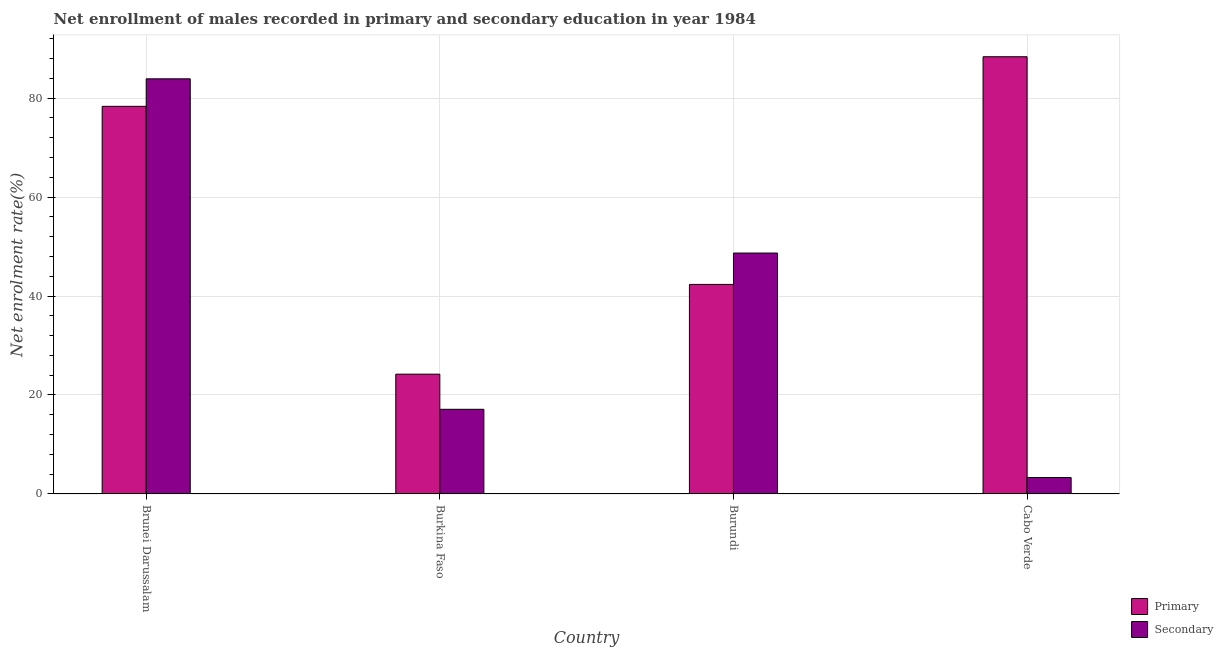How many different coloured bars are there?
Keep it short and to the point. 2. Are the number of bars per tick equal to the number of legend labels?
Keep it short and to the point. Yes. How many bars are there on the 2nd tick from the left?
Offer a terse response. 2. How many bars are there on the 2nd tick from the right?
Your response must be concise. 2. What is the label of the 4th group of bars from the left?
Your response must be concise. Cabo Verde. What is the enrollment rate in primary education in Brunei Darussalam?
Keep it short and to the point. 78.33. Across all countries, what is the maximum enrollment rate in primary education?
Offer a very short reply. 88.36. Across all countries, what is the minimum enrollment rate in primary education?
Give a very brief answer. 24.21. In which country was the enrollment rate in secondary education maximum?
Ensure brevity in your answer.  Brunei Darussalam. In which country was the enrollment rate in secondary education minimum?
Offer a very short reply. Cabo Verde. What is the total enrollment rate in primary education in the graph?
Your answer should be very brief. 233.25. What is the difference between the enrollment rate in secondary education in Brunei Darussalam and that in Cabo Verde?
Your response must be concise. 80.56. What is the difference between the enrollment rate in secondary education in Brunei Darussalam and the enrollment rate in primary education in Burundi?
Your answer should be compact. 41.55. What is the average enrollment rate in primary education per country?
Provide a short and direct response. 58.31. What is the difference between the enrollment rate in secondary education and enrollment rate in primary education in Burkina Faso?
Provide a short and direct response. -7.1. In how many countries, is the enrollment rate in secondary education greater than 44 %?
Keep it short and to the point. 2. What is the ratio of the enrollment rate in primary education in Brunei Darussalam to that in Burundi?
Offer a terse response. 1.85. Is the enrollment rate in primary education in Brunei Darussalam less than that in Burundi?
Keep it short and to the point. No. What is the difference between the highest and the second highest enrollment rate in primary education?
Make the answer very short. 10.02. What is the difference between the highest and the lowest enrollment rate in secondary education?
Provide a short and direct response. 80.56. In how many countries, is the enrollment rate in primary education greater than the average enrollment rate in primary education taken over all countries?
Offer a very short reply. 2. What does the 1st bar from the left in Brunei Darussalam represents?
Provide a short and direct response. Primary. What does the 1st bar from the right in Burundi represents?
Your answer should be very brief. Secondary. Are all the bars in the graph horizontal?
Your answer should be compact. No. How many countries are there in the graph?
Provide a succinct answer. 4. Are the values on the major ticks of Y-axis written in scientific E-notation?
Provide a succinct answer. No. Does the graph contain any zero values?
Provide a succinct answer. No. Where does the legend appear in the graph?
Provide a short and direct response. Bottom right. How many legend labels are there?
Offer a very short reply. 2. How are the legend labels stacked?
Give a very brief answer. Vertical. What is the title of the graph?
Your answer should be compact. Net enrollment of males recorded in primary and secondary education in year 1984. Does "Commercial service imports" appear as one of the legend labels in the graph?
Offer a terse response. No. What is the label or title of the X-axis?
Provide a short and direct response. Country. What is the label or title of the Y-axis?
Keep it short and to the point. Net enrolment rate(%). What is the Net enrolment rate(%) of Primary in Brunei Darussalam?
Your answer should be very brief. 78.33. What is the Net enrolment rate(%) of Secondary in Brunei Darussalam?
Make the answer very short. 83.89. What is the Net enrolment rate(%) in Primary in Burkina Faso?
Ensure brevity in your answer.  24.21. What is the Net enrolment rate(%) of Secondary in Burkina Faso?
Your answer should be compact. 17.11. What is the Net enrolment rate(%) in Primary in Burundi?
Keep it short and to the point. 42.35. What is the Net enrolment rate(%) of Secondary in Burundi?
Offer a very short reply. 48.68. What is the Net enrolment rate(%) in Primary in Cabo Verde?
Make the answer very short. 88.36. What is the Net enrolment rate(%) in Secondary in Cabo Verde?
Make the answer very short. 3.33. Across all countries, what is the maximum Net enrolment rate(%) in Primary?
Your response must be concise. 88.36. Across all countries, what is the maximum Net enrolment rate(%) in Secondary?
Offer a terse response. 83.89. Across all countries, what is the minimum Net enrolment rate(%) of Primary?
Your answer should be compact. 24.21. Across all countries, what is the minimum Net enrolment rate(%) in Secondary?
Give a very brief answer. 3.33. What is the total Net enrolment rate(%) in Primary in the graph?
Keep it short and to the point. 233.25. What is the total Net enrolment rate(%) of Secondary in the graph?
Offer a terse response. 153.01. What is the difference between the Net enrolment rate(%) in Primary in Brunei Darussalam and that in Burkina Faso?
Provide a succinct answer. 54.12. What is the difference between the Net enrolment rate(%) in Secondary in Brunei Darussalam and that in Burkina Faso?
Ensure brevity in your answer.  66.78. What is the difference between the Net enrolment rate(%) in Primary in Brunei Darussalam and that in Burundi?
Your answer should be very brief. 35.99. What is the difference between the Net enrolment rate(%) of Secondary in Brunei Darussalam and that in Burundi?
Your answer should be compact. 35.21. What is the difference between the Net enrolment rate(%) in Primary in Brunei Darussalam and that in Cabo Verde?
Make the answer very short. -10.02. What is the difference between the Net enrolment rate(%) of Secondary in Brunei Darussalam and that in Cabo Verde?
Make the answer very short. 80.56. What is the difference between the Net enrolment rate(%) of Primary in Burkina Faso and that in Burundi?
Give a very brief answer. -18.14. What is the difference between the Net enrolment rate(%) in Secondary in Burkina Faso and that in Burundi?
Keep it short and to the point. -31.57. What is the difference between the Net enrolment rate(%) of Primary in Burkina Faso and that in Cabo Verde?
Provide a succinct answer. -64.15. What is the difference between the Net enrolment rate(%) in Secondary in Burkina Faso and that in Cabo Verde?
Provide a succinct answer. 13.78. What is the difference between the Net enrolment rate(%) in Primary in Burundi and that in Cabo Verde?
Offer a very short reply. -46.01. What is the difference between the Net enrolment rate(%) of Secondary in Burundi and that in Cabo Verde?
Give a very brief answer. 45.36. What is the difference between the Net enrolment rate(%) of Primary in Brunei Darussalam and the Net enrolment rate(%) of Secondary in Burkina Faso?
Make the answer very short. 61.22. What is the difference between the Net enrolment rate(%) of Primary in Brunei Darussalam and the Net enrolment rate(%) of Secondary in Burundi?
Offer a terse response. 29.65. What is the difference between the Net enrolment rate(%) in Primary in Brunei Darussalam and the Net enrolment rate(%) in Secondary in Cabo Verde?
Offer a very short reply. 75.01. What is the difference between the Net enrolment rate(%) in Primary in Burkina Faso and the Net enrolment rate(%) in Secondary in Burundi?
Offer a very short reply. -24.47. What is the difference between the Net enrolment rate(%) of Primary in Burkina Faso and the Net enrolment rate(%) of Secondary in Cabo Verde?
Offer a terse response. 20.88. What is the difference between the Net enrolment rate(%) in Primary in Burundi and the Net enrolment rate(%) in Secondary in Cabo Verde?
Ensure brevity in your answer.  39.02. What is the average Net enrolment rate(%) in Primary per country?
Your response must be concise. 58.31. What is the average Net enrolment rate(%) of Secondary per country?
Provide a succinct answer. 38.25. What is the difference between the Net enrolment rate(%) of Primary and Net enrolment rate(%) of Secondary in Brunei Darussalam?
Provide a short and direct response. -5.56. What is the difference between the Net enrolment rate(%) of Primary and Net enrolment rate(%) of Secondary in Burkina Faso?
Offer a very short reply. 7.1. What is the difference between the Net enrolment rate(%) of Primary and Net enrolment rate(%) of Secondary in Burundi?
Offer a very short reply. -6.34. What is the difference between the Net enrolment rate(%) in Primary and Net enrolment rate(%) in Secondary in Cabo Verde?
Your response must be concise. 85.03. What is the ratio of the Net enrolment rate(%) in Primary in Brunei Darussalam to that in Burkina Faso?
Offer a terse response. 3.24. What is the ratio of the Net enrolment rate(%) in Secondary in Brunei Darussalam to that in Burkina Faso?
Your answer should be very brief. 4.9. What is the ratio of the Net enrolment rate(%) in Primary in Brunei Darussalam to that in Burundi?
Provide a succinct answer. 1.85. What is the ratio of the Net enrolment rate(%) of Secondary in Brunei Darussalam to that in Burundi?
Give a very brief answer. 1.72. What is the ratio of the Net enrolment rate(%) in Primary in Brunei Darussalam to that in Cabo Verde?
Provide a short and direct response. 0.89. What is the ratio of the Net enrolment rate(%) in Secondary in Brunei Darussalam to that in Cabo Verde?
Your response must be concise. 25.21. What is the ratio of the Net enrolment rate(%) of Primary in Burkina Faso to that in Burundi?
Make the answer very short. 0.57. What is the ratio of the Net enrolment rate(%) in Secondary in Burkina Faso to that in Burundi?
Offer a very short reply. 0.35. What is the ratio of the Net enrolment rate(%) of Primary in Burkina Faso to that in Cabo Verde?
Your answer should be very brief. 0.27. What is the ratio of the Net enrolment rate(%) in Secondary in Burkina Faso to that in Cabo Verde?
Offer a very short reply. 5.14. What is the ratio of the Net enrolment rate(%) of Primary in Burundi to that in Cabo Verde?
Your answer should be compact. 0.48. What is the ratio of the Net enrolment rate(%) in Secondary in Burundi to that in Cabo Verde?
Your answer should be compact. 14.63. What is the difference between the highest and the second highest Net enrolment rate(%) in Primary?
Provide a succinct answer. 10.02. What is the difference between the highest and the second highest Net enrolment rate(%) of Secondary?
Your response must be concise. 35.21. What is the difference between the highest and the lowest Net enrolment rate(%) of Primary?
Provide a short and direct response. 64.15. What is the difference between the highest and the lowest Net enrolment rate(%) in Secondary?
Your answer should be very brief. 80.56. 